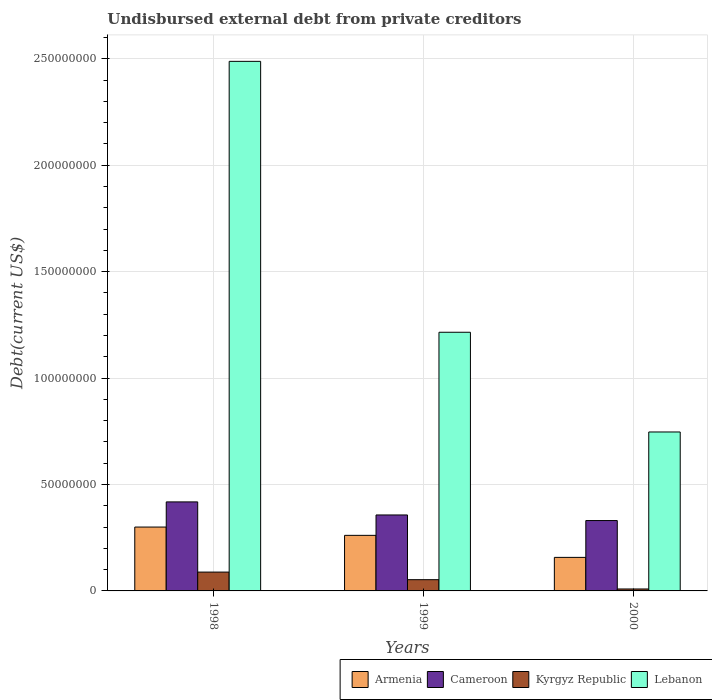What is the total debt in Armenia in 2000?
Provide a succinct answer. 1.58e+07. Across all years, what is the maximum total debt in Armenia?
Your answer should be compact. 3.00e+07. Across all years, what is the minimum total debt in Lebanon?
Make the answer very short. 7.47e+07. In which year was the total debt in Kyrgyz Republic maximum?
Offer a terse response. 1998. What is the total total debt in Kyrgyz Republic in the graph?
Provide a succinct answer. 1.50e+07. What is the difference between the total debt in Kyrgyz Republic in 1998 and that in 1999?
Provide a short and direct response. 3.57e+06. What is the difference between the total debt in Kyrgyz Republic in 2000 and the total debt in Lebanon in 1998?
Your answer should be compact. -2.48e+08. What is the average total debt in Kyrgyz Republic per year?
Your answer should be very brief. 5.02e+06. In the year 1998, what is the difference between the total debt in Lebanon and total debt in Kyrgyz Republic?
Provide a succinct answer. 2.40e+08. What is the ratio of the total debt in Kyrgyz Republic in 1998 to that in 1999?
Your answer should be compact. 1.68. Is the total debt in Cameroon in 1998 less than that in 2000?
Your answer should be very brief. No. Is the difference between the total debt in Lebanon in 1999 and 2000 greater than the difference between the total debt in Kyrgyz Republic in 1999 and 2000?
Keep it short and to the point. Yes. What is the difference between the highest and the second highest total debt in Cameroon?
Provide a short and direct response. 6.13e+06. What is the difference between the highest and the lowest total debt in Armenia?
Offer a terse response. 1.42e+07. In how many years, is the total debt in Lebanon greater than the average total debt in Lebanon taken over all years?
Offer a terse response. 1. What does the 2nd bar from the left in 1999 represents?
Make the answer very short. Cameroon. What does the 1st bar from the right in 1998 represents?
Your answer should be very brief. Lebanon. How many bars are there?
Offer a very short reply. 12. Are all the bars in the graph horizontal?
Keep it short and to the point. No. How many years are there in the graph?
Your answer should be very brief. 3. Does the graph contain grids?
Provide a short and direct response. Yes. Where does the legend appear in the graph?
Keep it short and to the point. Bottom right. What is the title of the graph?
Keep it short and to the point. Undisbursed external debt from private creditors. Does "Bermuda" appear as one of the legend labels in the graph?
Provide a short and direct response. No. What is the label or title of the X-axis?
Your response must be concise. Years. What is the label or title of the Y-axis?
Offer a terse response. Debt(current US$). What is the Debt(current US$) of Armenia in 1998?
Keep it short and to the point. 3.00e+07. What is the Debt(current US$) in Cameroon in 1998?
Ensure brevity in your answer.  4.18e+07. What is the Debt(current US$) of Kyrgyz Republic in 1998?
Make the answer very short. 8.85e+06. What is the Debt(current US$) in Lebanon in 1998?
Offer a very short reply. 2.49e+08. What is the Debt(current US$) in Armenia in 1999?
Give a very brief answer. 2.61e+07. What is the Debt(current US$) in Cameroon in 1999?
Keep it short and to the point. 3.57e+07. What is the Debt(current US$) in Kyrgyz Republic in 1999?
Offer a terse response. 5.28e+06. What is the Debt(current US$) of Lebanon in 1999?
Provide a short and direct response. 1.22e+08. What is the Debt(current US$) in Armenia in 2000?
Your response must be concise. 1.58e+07. What is the Debt(current US$) in Cameroon in 2000?
Provide a short and direct response. 3.31e+07. What is the Debt(current US$) in Kyrgyz Republic in 2000?
Offer a very short reply. 9.12e+05. What is the Debt(current US$) of Lebanon in 2000?
Provide a succinct answer. 7.47e+07. Across all years, what is the maximum Debt(current US$) of Armenia?
Provide a short and direct response. 3.00e+07. Across all years, what is the maximum Debt(current US$) of Cameroon?
Your answer should be very brief. 4.18e+07. Across all years, what is the maximum Debt(current US$) in Kyrgyz Republic?
Ensure brevity in your answer.  8.85e+06. Across all years, what is the maximum Debt(current US$) of Lebanon?
Give a very brief answer. 2.49e+08. Across all years, what is the minimum Debt(current US$) of Armenia?
Your answer should be compact. 1.58e+07. Across all years, what is the minimum Debt(current US$) of Cameroon?
Your answer should be compact. 3.31e+07. Across all years, what is the minimum Debt(current US$) in Kyrgyz Republic?
Ensure brevity in your answer.  9.12e+05. Across all years, what is the minimum Debt(current US$) in Lebanon?
Your response must be concise. 7.47e+07. What is the total Debt(current US$) of Armenia in the graph?
Keep it short and to the point. 7.19e+07. What is the total Debt(current US$) in Cameroon in the graph?
Keep it short and to the point. 1.11e+08. What is the total Debt(current US$) in Kyrgyz Republic in the graph?
Your answer should be very brief. 1.50e+07. What is the total Debt(current US$) of Lebanon in the graph?
Give a very brief answer. 4.45e+08. What is the difference between the Debt(current US$) of Armenia in 1998 and that in 1999?
Provide a succinct answer. 3.90e+06. What is the difference between the Debt(current US$) of Cameroon in 1998 and that in 1999?
Keep it short and to the point. 6.13e+06. What is the difference between the Debt(current US$) of Kyrgyz Republic in 1998 and that in 1999?
Offer a very short reply. 3.57e+06. What is the difference between the Debt(current US$) of Lebanon in 1998 and that in 1999?
Ensure brevity in your answer.  1.27e+08. What is the difference between the Debt(current US$) of Armenia in 1998 and that in 2000?
Make the answer very short. 1.42e+07. What is the difference between the Debt(current US$) of Cameroon in 1998 and that in 2000?
Your answer should be compact. 8.76e+06. What is the difference between the Debt(current US$) in Kyrgyz Republic in 1998 and that in 2000?
Offer a terse response. 7.94e+06. What is the difference between the Debt(current US$) of Lebanon in 1998 and that in 2000?
Ensure brevity in your answer.  1.74e+08. What is the difference between the Debt(current US$) in Armenia in 1999 and that in 2000?
Your answer should be compact. 1.04e+07. What is the difference between the Debt(current US$) in Cameroon in 1999 and that in 2000?
Your answer should be very brief. 2.63e+06. What is the difference between the Debt(current US$) in Kyrgyz Republic in 1999 and that in 2000?
Offer a terse response. 4.37e+06. What is the difference between the Debt(current US$) of Lebanon in 1999 and that in 2000?
Your response must be concise. 4.68e+07. What is the difference between the Debt(current US$) of Armenia in 1998 and the Debt(current US$) of Cameroon in 1999?
Make the answer very short. -5.68e+06. What is the difference between the Debt(current US$) of Armenia in 1998 and the Debt(current US$) of Kyrgyz Republic in 1999?
Keep it short and to the point. 2.47e+07. What is the difference between the Debt(current US$) in Armenia in 1998 and the Debt(current US$) in Lebanon in 1999?
Make the answer very short. -9.15e+07. What is the difference between the Debt(current US$) of Cameroon in 1998 and the Debt(current US$) of Kyrgyz Republic in 1999?
Your response must be concise. 3.65e+07. What is the difference between the Debt(current US$) of Cameroon in 1998 and the Debt(current US$) of Lebanon in 1999?
Keep it short and to the point. -7.97e+07. What is the difference between the Debt(current US$) in Kyrgyz Republic in 1998 and the Debt(current US$) in Lebanon in 1999?
Offer a very short reply. -1.13e+08. What is the difference between the Debt(current US$) of Armenia in 1998 and the Debt(current US$) of Cameroon in 2000?
Give a very brief answer. -3.05e+06. What is the difference between the Debt(current US$) in Armenia in 1998 and the Debt(current US$) in Kyrgyz Republic in 2000?
Your answer should be compact. 2.91e+07. What is the difference between the Debt(current US$) of Armenia in 1998 and the Debt(current US$) of Lebanon in 2000?
Your answer should be very brief. -4.47e+07. What is the difference between the Debt(current US$) of Cameroon in 1998 and the Debt(current US$) of Kyrgyz Republic in 2000?
Offer a terse response. 4.09e+07. What is the difference between the Debt(current US$) in Cameroon in 1998 and the Debt(current US$) in Lebanon in 2000?
Keep it short and to the point. -3.28e+07. What is the difference between the Debt(current US$) of Kyrgyz Republic in 1998 and the Debt(current US$) of Lebanon in 2000?
Provide a succinct answer. -6.58e+07. What is the difference between the Debt(current US$) of Armenia in 1999 and the Debt(current US$) of Cameroon in 2000?
Offer a very short reply. -6.95e+06. What is the difference between the Debt(current US$) of Armenia in 1999 and the Debt(current US$) of Kyrgyz Republic in 2000?
Your response must be concise. 2.52e+07. What is the difference between the Debt(current US$) in Armenia in 1999 and the Debt(current US$) in Lebanon in 2000?
Offer a very short reply. -4.86e+07. What is the difference between the Debt(current US$) of Cameroon in 1999 and the Debt(current US$) of Kyrgyz Republic in 2000?
Ensure brevity in your answer.  3.48e+07. What is the difference between the Debt(current US$) in Cameroon in 1999 and the Debt(current US$) in Lebanon in 2000?
Give a very brief answer. -3.90e+07. What is the difference between the Debt(current US$) in Kyrgyz Republic in 1999 and the Debt(current US$) in Lebanon in 2000?
Your answer should be compact. -6.94e+07. What is the average Debt(current US$) in Armenia per year?
Keep it short and to the point. 2.40e+07. What is the average Debt(current US$) of Cameroon per year?
Offer a terse response. 3.68e+07. What is the average Debt(current US$) of Kyrgyz Republic per year?
Provide a succinct answer. 5.02e+06. What is the average Debt(current US$) in Lebanon per year?
Give a very brief answer. 1.48e+08. In the year 1998, what is the difference between the Debt(current US$) in Armenia and Debt(current US$) in Cameroon?
Make the answer very short. -1.18e+07. In the year 1998, what is the difference between the Debt(current US$) of Armenia and Debt(current US$) of Kyrgyz Republic?
Offer a very short reply. 2.11e+07. In the year 1998, what is the difference between the Debt(current US$) of Armenia and Debt(current US$) of Lebanon?
Provide a short and direct response. -2.19e+08. In the year 1998, what is the difference between the Debt(current US$) of Cameroon and Debt(current US$) of Kyrgyz Republic?
Your response must be concise. 3.30e+07. In the year 1998, what is the difference between the Debt(current US$) in Cameroon and Debt(current US$) in Lebanon?
Make the answer very short. -2.07e+08. In the year 1998, what is the difference between the Debt(current US$) of Kyrgyz Republic and Debt(current US$) of Lebanon?
Your answer should be very brief. -2.40e+08. In the year 1999, what is the difference between the Debt(current US$) of Armenia and Debt(current US$) of Cameroon?
Your response must be concise. -9.58e+06. In the year 1999, what is the difference between the Debt(current US$) of Armenia and Debt(current US$) of Kyrgyz Republic?
Your answer should be very brief. 2.08e+07. In the year 1999, what is the difference between the Debt(current US$) in Armenia and Debt(current US$) in Lebanon?
Give a very brief answer. -9.54e+07. In the year 1999, what is the difference between the Debt(current US$) of Cameroon and Debt(current US$) of Kyrgyz Republic?
Provide a succinct answer. 3.04e+07. In the year 1999, what is the difference between the Debt(current US$) in Cameroon and Debt(current US$) in Lebanon?
Your answer should be very brief. -8.58e+07. In the year 1999, what is the difference between the Debt(current US$) of Kyrgyz Republic and Debt(current US$) of Lebanon?
Your answer should be very brief. -1.16e+08. In the year 2000, what is the difference between the Debt(current US$) in Armenia and Debt(current US$) in Cameroon?
Keep it short and to the point. -1.73e+07. In the year 2000, what is the difference between the Debt(current US$) of Armenia and Debt(current US$) of Kyrgyz Republic?
Provide a short and direct response. 1.48e+07. In the year 2000, what is the difference between the Debt(current US$) in Armenia and Debt(current US$) in Lebanon?
Make the answer very short. -5.89e+07. In the year 2000, what is the difference between the Debt(current US$) in Cameroon and Debt(current US$) in Kyrgyz Republic?
Keep it short and to the point. 3.21e+07. In the year 2000, what is the difference between the Debt(current US$) of Cameroon and Debt(current US$) of Lebanon?
Ensure brevity in your answer.  -4.16e+07. In the year 2000, what is the difference between the Debt(current US$) in Kyrgyz Republic and Debt(current US$) in Lebanon?
Keep it short and to the point. -7.38e+07. What is the ratio of the Debt(current US$) of Armenia in 1998 to that in 1999?
Ensure brevity in your answer.  1.15. What is the ratio of the Debt(current US$) of Cameroon in 1998 to that in 1999?
Your answer should be very brief. 1.17. What is the ratio of the Debt(current US$) of Kyrgyz Republic in 1998 to that in 1999?
Give a very brief answer. 1.68. What is the ratio of the Debt(current US$) in Lebanon in 1998 to that in 1999?
Your answer should be very brief. 2.05. What is the ratio of the Debt(current US$) of Armenia in 1998 to that in 2000?
Offer a very short reply. 1.9. What is the ratio of the Debt(current US$) in Cameroon in 1998 to that in 2000?
Make the answer very short. 1.27. What is the ratio of the Debt(current US$) in Kyrgyz Republic in 1998 to that in 2000?
Ensure brevity in your answer.  9.71. What is the ratio of the Debt(current US$) in Lebanon in 1998 to that in 2000?
Keep it short and to the point. 3.33. What is the ratio of the Debt(current US$) of Armenia in 1999 to that in 2000?
Provide a succinct answer. 1.66. What is the ratio of the Debt(current US$) in Cameroon in 1999 to that in 2000?
Provide a short and direct response. 1.08. What is the ratio of the Debt(current US$) of Kyrgyz Republic in 1999 to that in 2000?
Your answer should be compact. 5.79. What is the ratio of the Debt(current US$) of Lebanon in 1999 to that in 2000?
Provide a short and direct response. 1.63. What is the difference between the highest and the second highest Debt(current US$) of Armenia?
Your answer should be compact. 3.90e+06. What is the difference between the highest and the second highest Debt(current US$) of Cameroon?
Your response must be concise. 6.13e+06. What is the difference between the highest and the second highest Debt(current US$) in Kyrgyz Republic?
Your answer should be compact. 3.57e+06. What is the difference between the highest and the second highest Debt(current US$) of Lebanon?
Provide a short and direct response. 1.27e+08. What is the difference between the highest and the lowest Debt(current US$) in Armenia?
Your answer should be compact. 1.42e+07. What is the difference between the highest and the lowest Debt(current US$) in Cameroon?
Keep it short and to the point. 8.76e+06. What is the difference between the highest and the lowest Debt(current US$) in Kyrgyz Republic?
Make the answer very short. 7.94e+06. What is the difference between the highest and the lowest Debt(current US$) in Lebanon?
Your answer should be compact. 1.74e+08. 